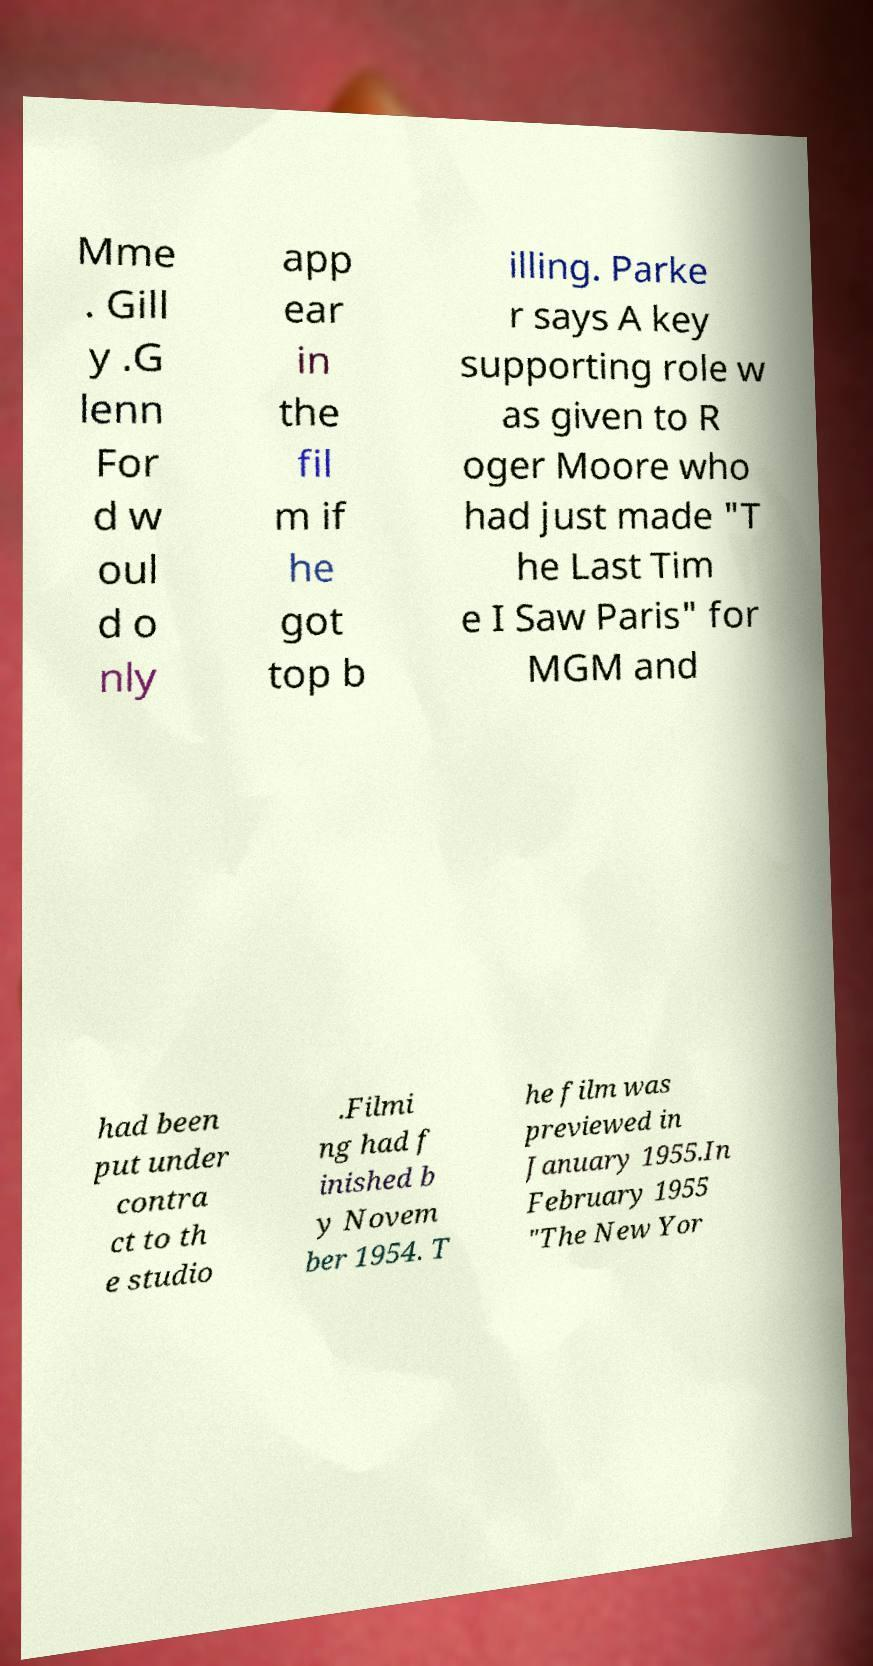Can you read and provide the text displayed in the image?This photo seems to have some interesting text. Can you extract and type it out for me? Mme . Gill y .G lenn For d w oul d o nly app ear in the fil m if he got top b illing. Parke r says A key supporting role w as given to R oger Moore who had just made "T he Last Tim e I Saw Paris" for MGM and had been put under contra ct to th e studio .Filmi ng had f inished b y Novem ber 1954. T he film was previewed in January 1955.In February 1955 "The New Yor 